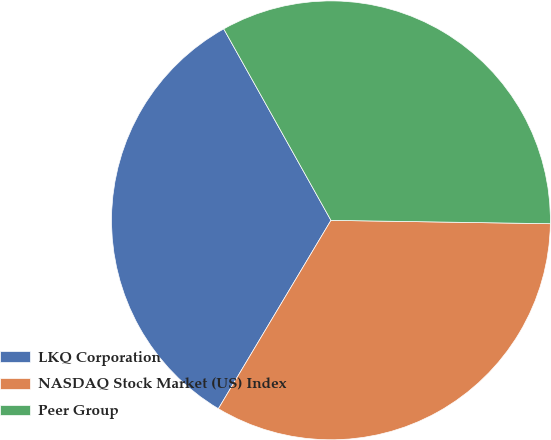Convert chart to OTSL. <chart><loc_0><loc_0><loc_500><loc_500><pie_chart><fcel>LKQ Corporation<fcel>NASDAQ Stock Market (US) Index<fcel>Peer Group<nl><fcel>33.3%<fcel>33.33%<fcel>33.37%<nl></chart> 